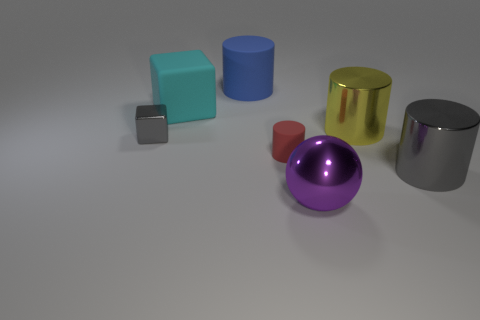Subtract all red matte cylinders. How many cylinders are left? 3 Add 1 small brown metallic cubes. How many objects exist? 8 Subtract all blue cylinders. How many cylinders are left? 3 Subtract all cylinders. How many objects are left? 3 Subtract 2 cylinders. How many cylinders are left? 2 Subtract 0 red cubes. How many objects are left? 7 Subtract all purple cylinders. Subtract all cyan balls. How many cylinders are left? 4 Subtract all cyan rubber cubes. Subtract all gray objects. How many objects are left? 4 Add 2 big purple shiny balls. How many big purple shiny balls are left? 3 Add 3 large cyan matte blocks. How many large cyan matte blocks exist? 4 